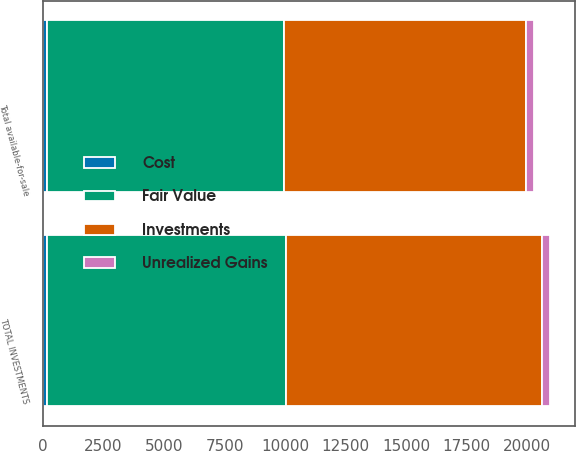Convert chart to OTSL. <chart><loc_0><loc_0><loc_500><loc_500><stacked_bar_chart><ecel><fcel>Total available-for-sale<fcel>TOTAL INVESTMENTS<nl><fcel>Investments<fcel>10000<fcel>10571<nl><fcel>Cost<fcel>147<fcel>162<nl><fcel>Unrealized Gains<fcel>338<fcel>339<nl><fcel>Fair Value<fcel>9809<fcel>9888<nl></chart> 